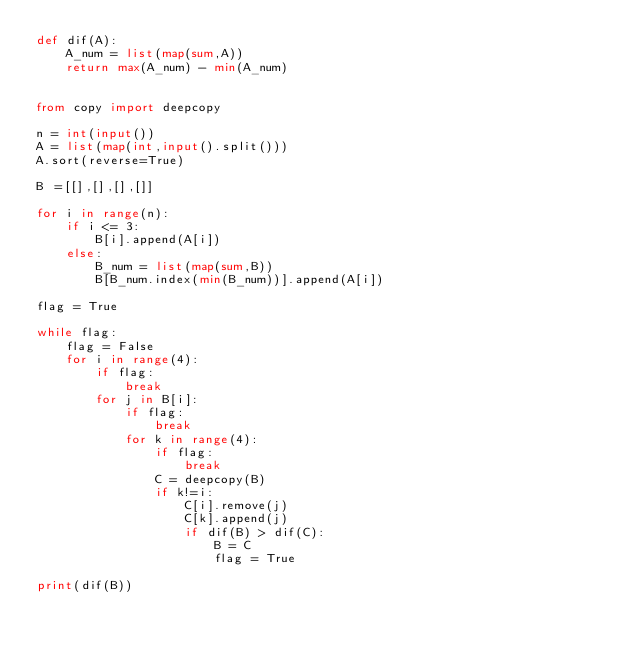<code> <loc_0><loc_0><loc_500><loc_500><_Python_>def dif(A):
    A_num = list(map(sum,A))
    return max(A_num) - min(A_num)


from copy import deepcopy

n = int(input())
A = list(map(int,input().split()))
A.sort(reverse=True)

B =[[],[],[],[]]

for i in range(n):
    if i <= 3:
        B[i].append(A[i])
    else:
        B_num = list(map(sum,B))
        B[B_num.index(min(B_num))].append(A[i])

flag = True

while flag:
    flag = False
    for i in range(4):
        if flag:
            break
        for j in B[i]:
            if flag:
                break
            for k in range(4):
                if flag:
                    break
                C = deepcopy(B)
                if k!=i:
                    C[i].remove(j)
                    C[k].append(j)
                    if dif(B) > dif(C):
                        B = C
                        flag = True

print(dif(B))

</code> 